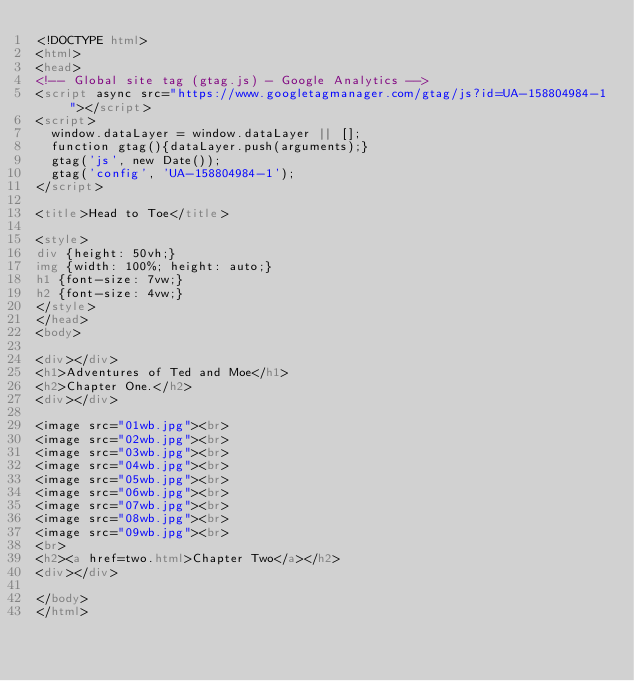Convert code to text. <code><loc_0><loc_0><loc_500><loc_500><_HTML_><!DOCTYPE html>
<html>
<head>
<!-- Global site tag (gtag.js) - Google Analytics -->
<script async src="https://www.googletagmanager.com/gtag/js?id=UA-158804984-1"></script>
<script>
  window.dataLayer = window.dataLayer || [];
  function gtag(){dataLayer.push(arguments);}
  gtag('js', new Date());
  gtag('config', 'UA-158804984-1');
</script>

<title>Head to Toe</title>

<style>
div {height: 50vh;}
img {width: 100%; height: auto;}
h1 {font-size: 7vw;}
h2 {font-size: 4vw;}
</style>
</head>
<body>

<div></div>
<h1>Adventures of Ted and Moe</h1>
<h2>Chapter One.</h2>
<div></div>

<image src="01wb.jpg"><br>
<image src="02wb.jpg"><br>
<image src="03wb.jpg"><br>
<image src="04wb.jpg"><br>
<image src="05wb.jpg"><br>
<image src="06wb.jpg"><br>
<image src="07wb.jpg"><br>
<image src="08wb.jpg"><br>
<image src="09wb.jpg"><br>
<br>
<h2><a href=two.html>Chapter Two</a></h2>
<div></div>

</body>
</html>
</code> 